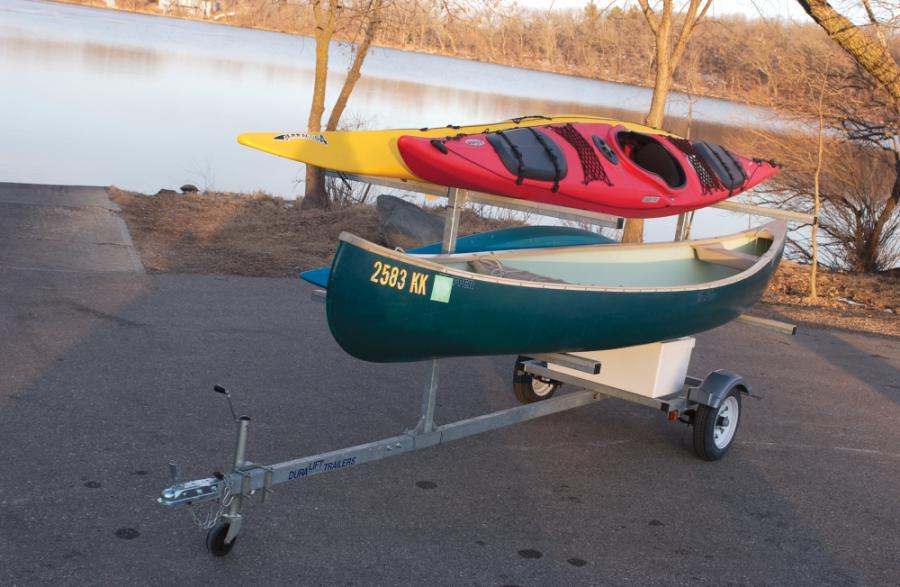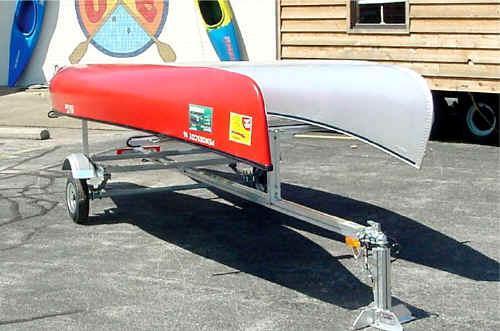The first image is the image on the left, the second image is the image on the right. Examine the images to the left and right. Is the description "One of the trailers is rectangular in shape." accurate? Answer yes or no. No. The first image is the image on the left, the second image is the image on the right. Evaluate the accuracy of this statement regarding the images: "An image shows an unattached trailer loaded with only two canoes.". Is it true? Answer yes or no. Yes. 